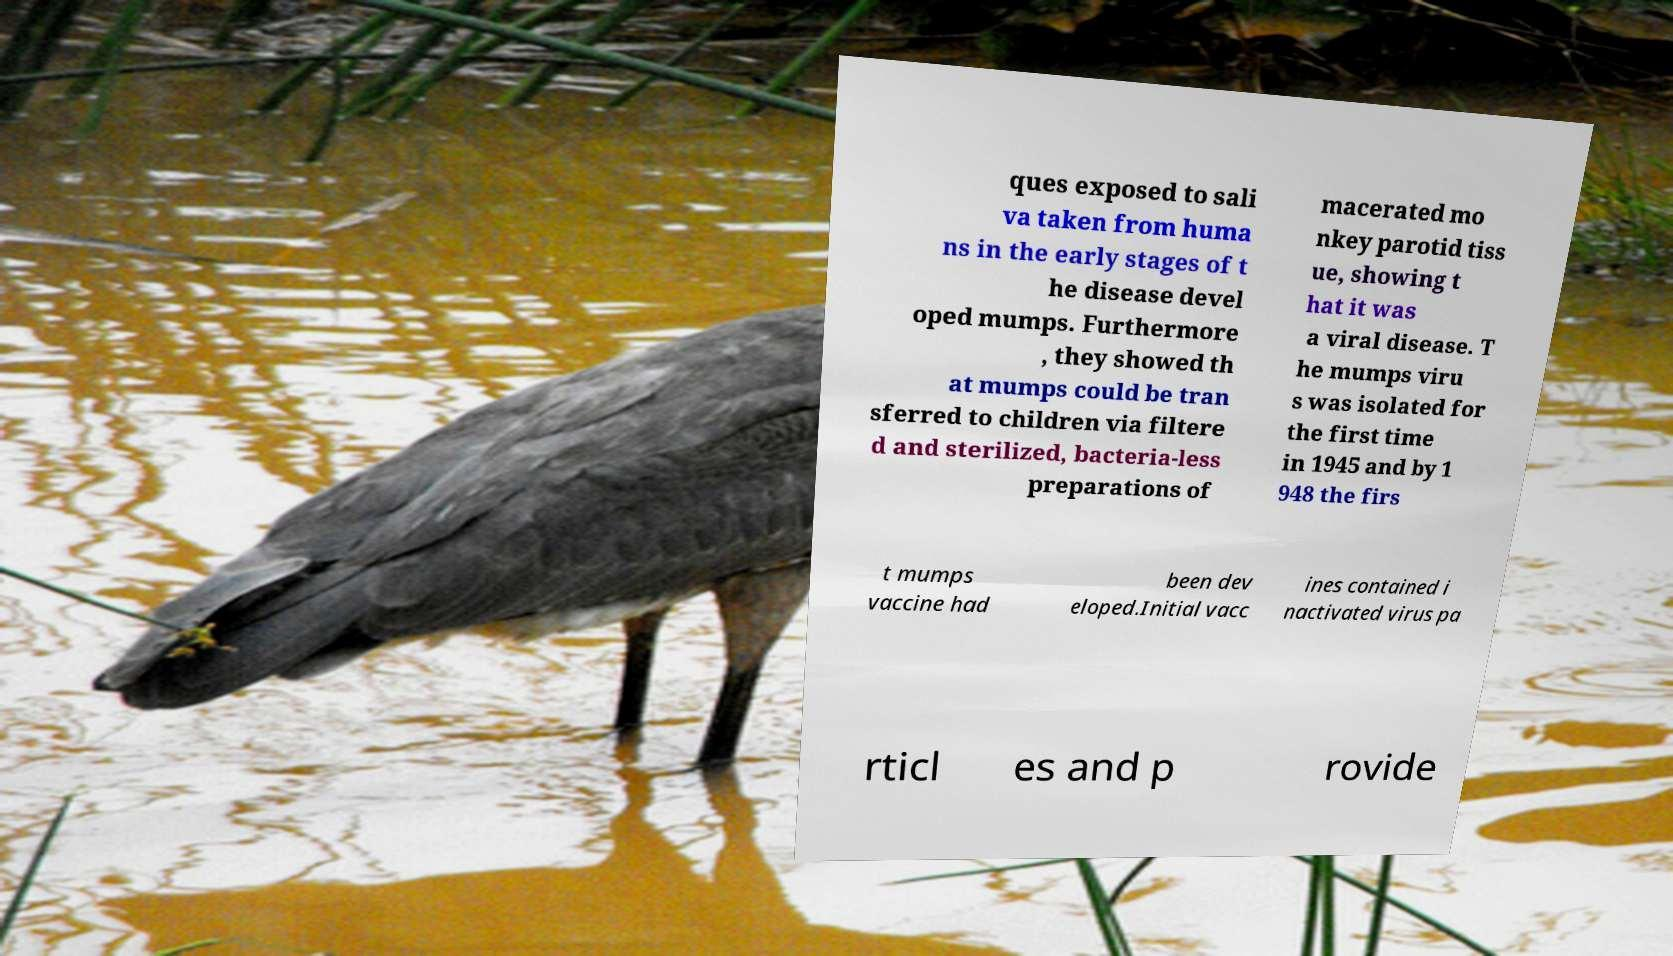For documentation purposes, I need the text within this image transcribed. Could you provide that? ques exposed to sali va taken from huma ns in the early stages of t he disease devel oped mumps. Furthermore , they showed th at mumps could be tran sferred to children via filtere d and sterilized, bacteria-less preparations of macerated mo nkey parotid tiss ue, showing t hat it was a viral disease. T he mumps viru s was isolated for the first time in 1945 and by 1 948 the firs t mumps vaccine had been dev eloped.Initial vacc ines contained i nactivated virus pa rticl es and p rovide 